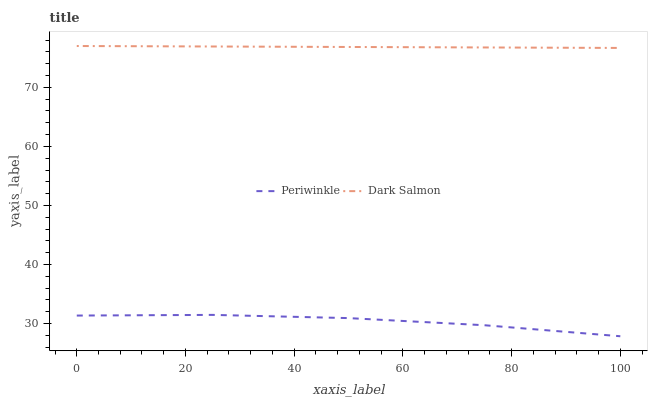Does Periwinkle have the minimum area under the curve?
Answer yes or no. Yes. Does Dark Salmon have the maximum area under the curve?
Answer yes or no. Yes. Does Dark Salmon have the minimum area under the curve?
Answer yes or no. No. Is Dark Salmon the smoothest?
Answer yes or no. Yes. Is Periwinkle the roughest?
Answer yes or no. Yes. Is Dark Salmon the roughest?
Answer yes or no. No. Does Periwinkle have the lowest value?
Answer yes or no. Yes. Does Dark Salmon have the lowest value?
Answer yes or no. No. Does Dark Salmon have the highest value?
Answer yes or no. Yes. Is Periwinkle less than Dark Salmon?
Answer yes or no. Yes. Is Dark Salmon greater than Periwinkle?
Answer yes or no. Yes. Does Periwinkle intersect Dark Salmon?
Answer yes or no. No. 